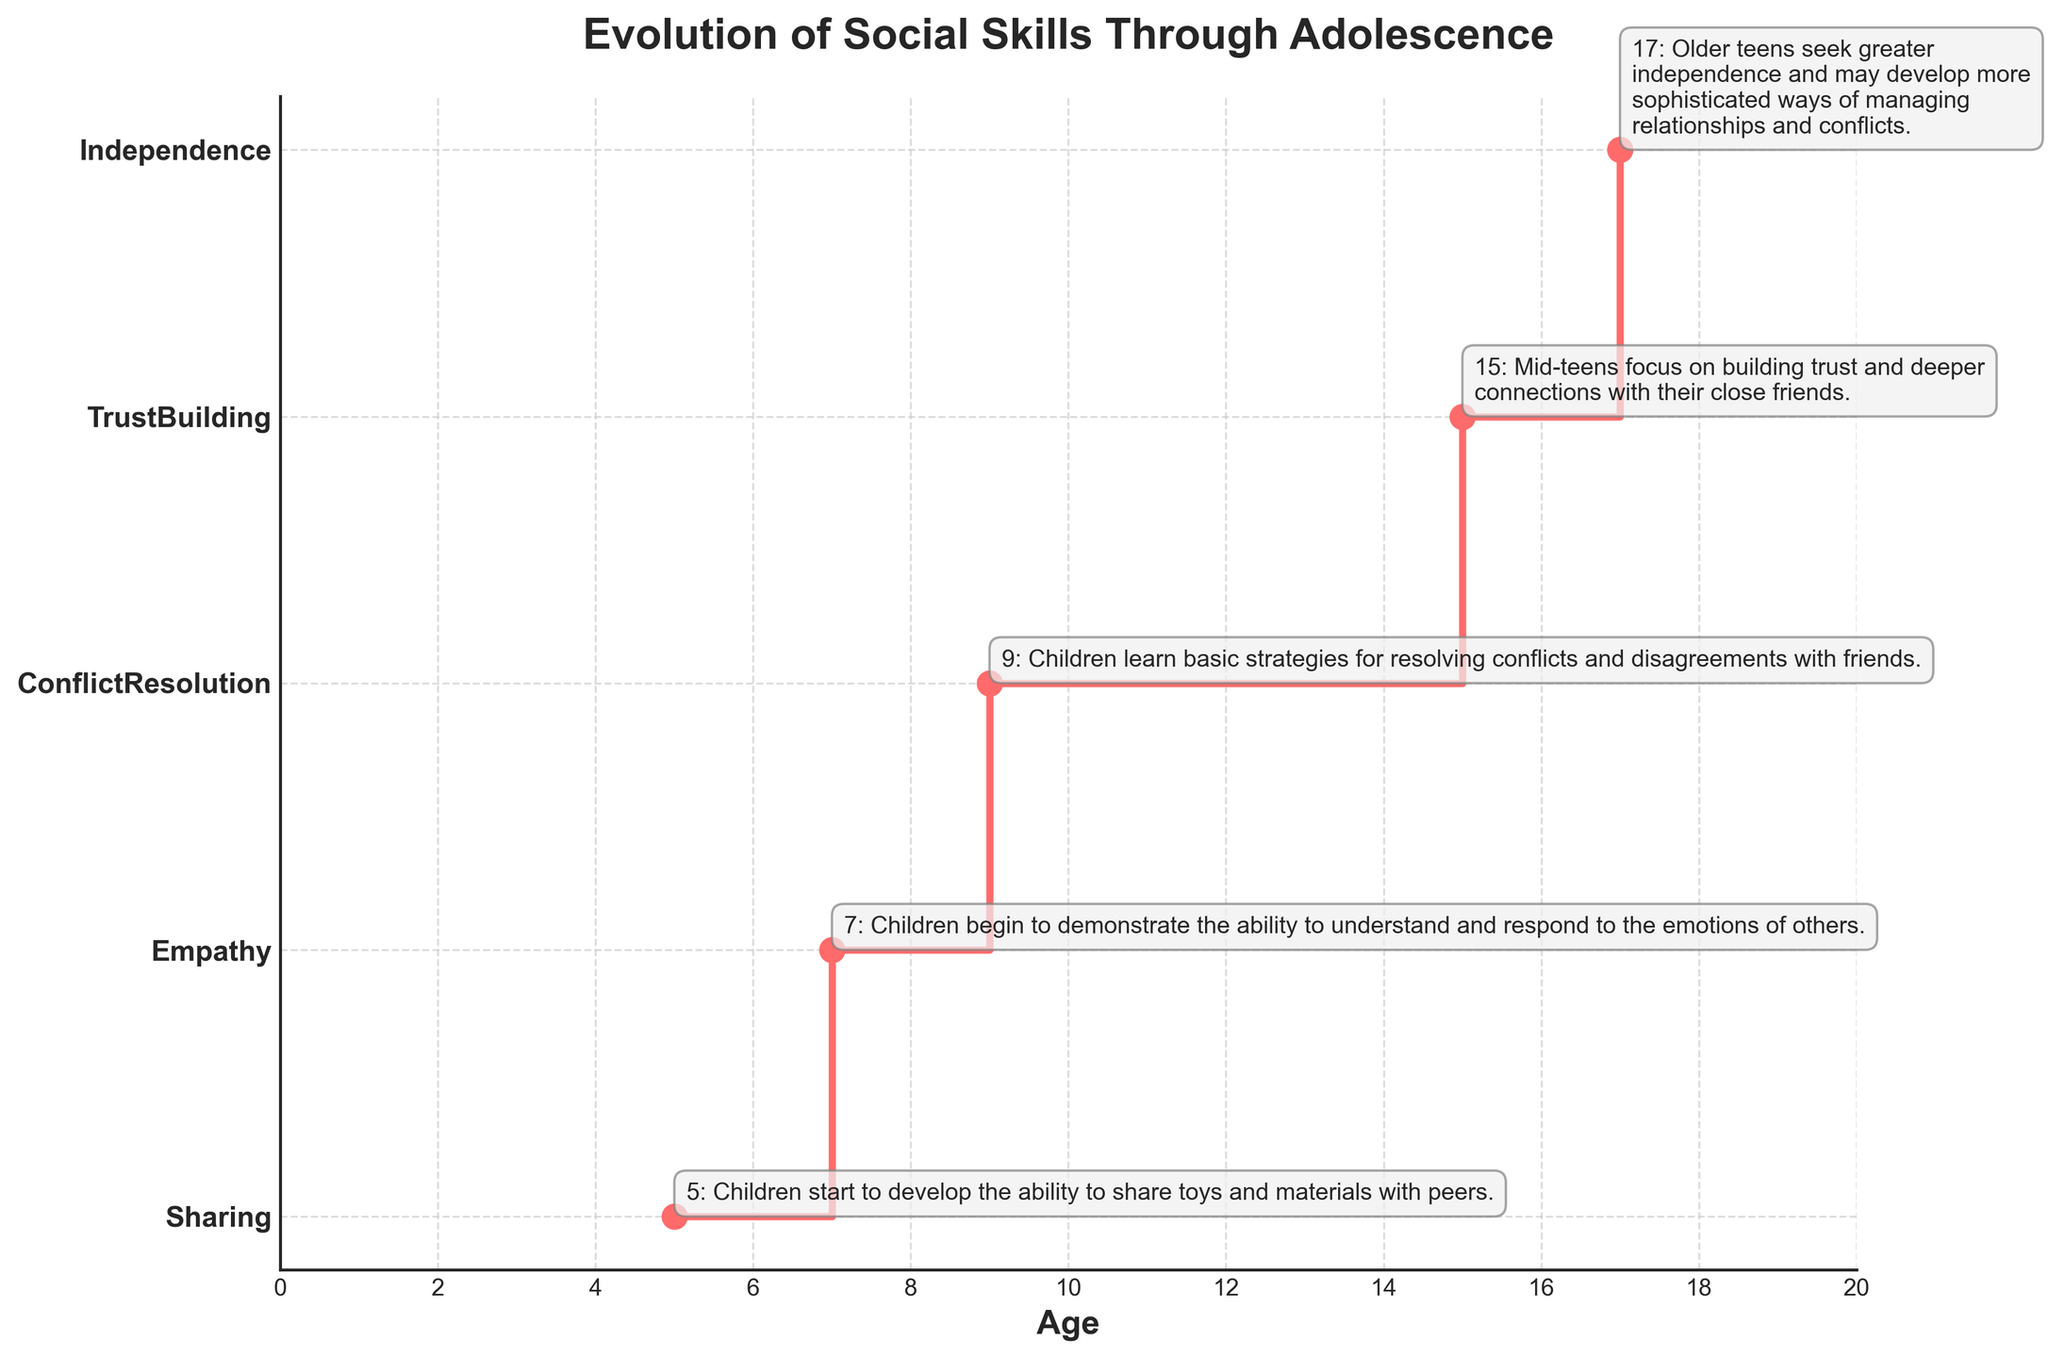What is the title of the figure? The title is typically located at the top of the figure, usually in a larger or bolder font. Here, it is prominently displayed in bold and larger size.
Answer: Evolution of Social Skills Through Adolescence How many key age milestones are highlighted in the figure? Each milestone is marked by a step in the stair plot, indicated by the markers on the line and y-axis labels. Counting these gives the total number of milestones.
Answer: 5 At what age do children start developing the ability to share toys and materials with peers? According to the annotation at the first step of the plot where age is labeled as 5, the social skill is Sharing.
Answer: 5 Which social skill is associated with the age of 9? The label on the y-axis next to the marker for age 9 reveals the social skill. The step plot also guides from the age to the respective skill.
Answer: ConflictResolution What is the age difference between when children develop empathy and when they focus on building trust with friends? Identify the ages for empathy and trust-building from the annotations (7 and 15), then calculate the difference.
Answer: 8 Which social skill comes immediately after children start to share? Look at the next step in the plot after the one marked at age 5 for Sharing to identify the subsequent skill at age 7.
Answer: Empathy How many years apart are the milestones for TrustBuilding and Independence? Determine the ages for TrustBuilding (15) and Independence (17) from the plot annotations and calculate the difference.
Answer: 2 What happens at age 9 according to the figure? Refer to the annotation on the figure for age 9 to find the description attached to that milestone.
Answer: Children learn basic strategies for resolving conflicts and disagreements with friends What is the color of the line used in the stair plot? Observing the visual attributes of the plot, the color of the line connecting the steps is a vibrant shade.
Answer: Red (specifically, a shade of red) How many social skills are identified in the plot before the age of 10? The plot shows steps at ages 5, 7, and 9, each corresponding to a social skill.
Answer: 3 